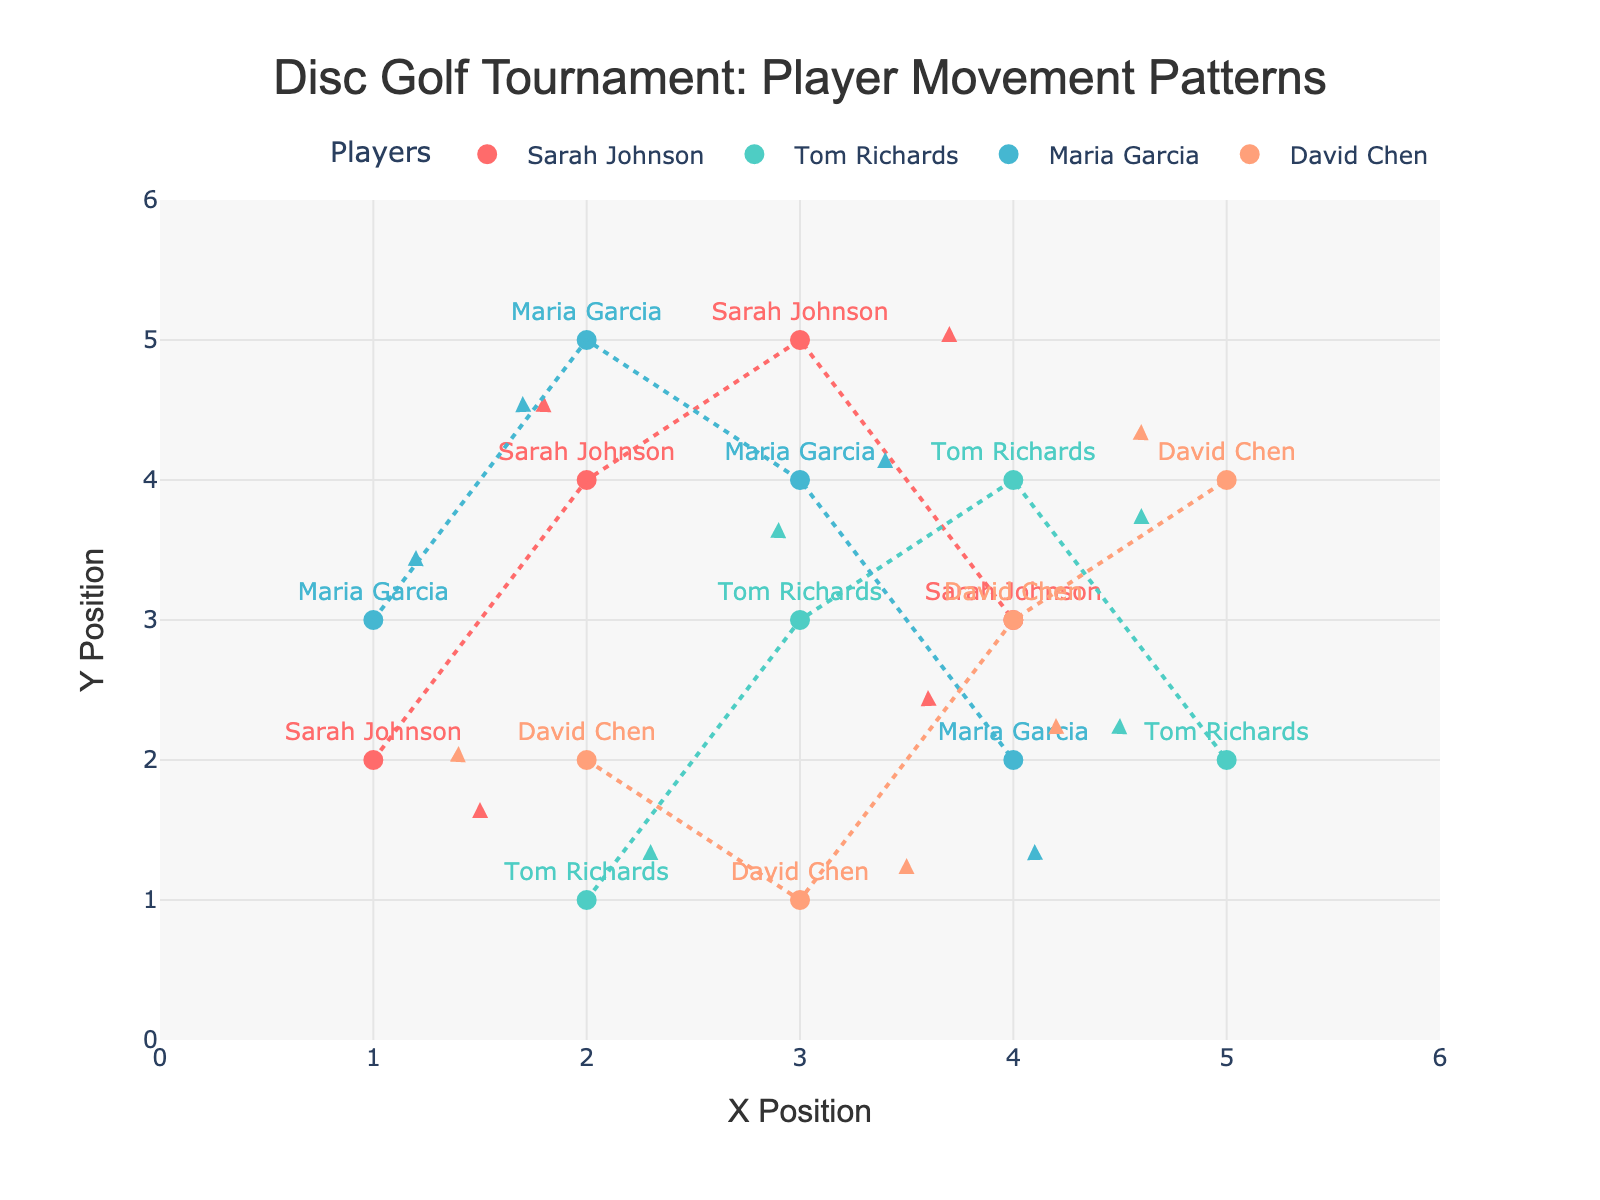What is the title of the plot? The title is displayed at the top of the plot and reads "Disc Golf Tournament: Player Movement Patterns."
Answer: Disc Golf Tournament: Player Movement Patterns Which axis shows the X Position? The X axis is labeled "X Position" at the bottom of the plot.
Answer: X axis What is the maximum X position on the plot? The X axis ranges from 0 to 6, so the maximum X position is 6.
Answer: 6 How many players are tracked in this plot? There are four players tracked, each represented by different colors and names annotated near their starting positions.
Answer: Four Which player has a movement pattern with a downward trend overall? By observing the arrows and lines, Sarah Johnson’s overall trend moves downward considering her final positions are lower than her initial.
Answer: Sarah Johnson Which player has the steepest single movement up? Tom Richards has a steep movement up from (2,1) to (2.3,1.4) and further to (3,3.7) which is the most pronounced vertical movement.
Answer: Tom Richards What overall pattern can you observe in David Chen’s movements? David Chen's movements appear scattered but generally trend from left to right and slightly upwards.
Answer: Left to right, slightly upward Which player covered the most distance between their initial and final position? By looking at the lengths of the arrows, Sarah Johnson covers a larger distance from her initial to final positions (from approximate coordinates (1,2) to (4,-0.2)).
Answer: Sarah Johnson Which player mostly stayed in a central location? Maria Garcia’s movements remain close to the central part of the plot, ranging primarily between coordinates that feel centralized.
Answer: Maria Garcia 